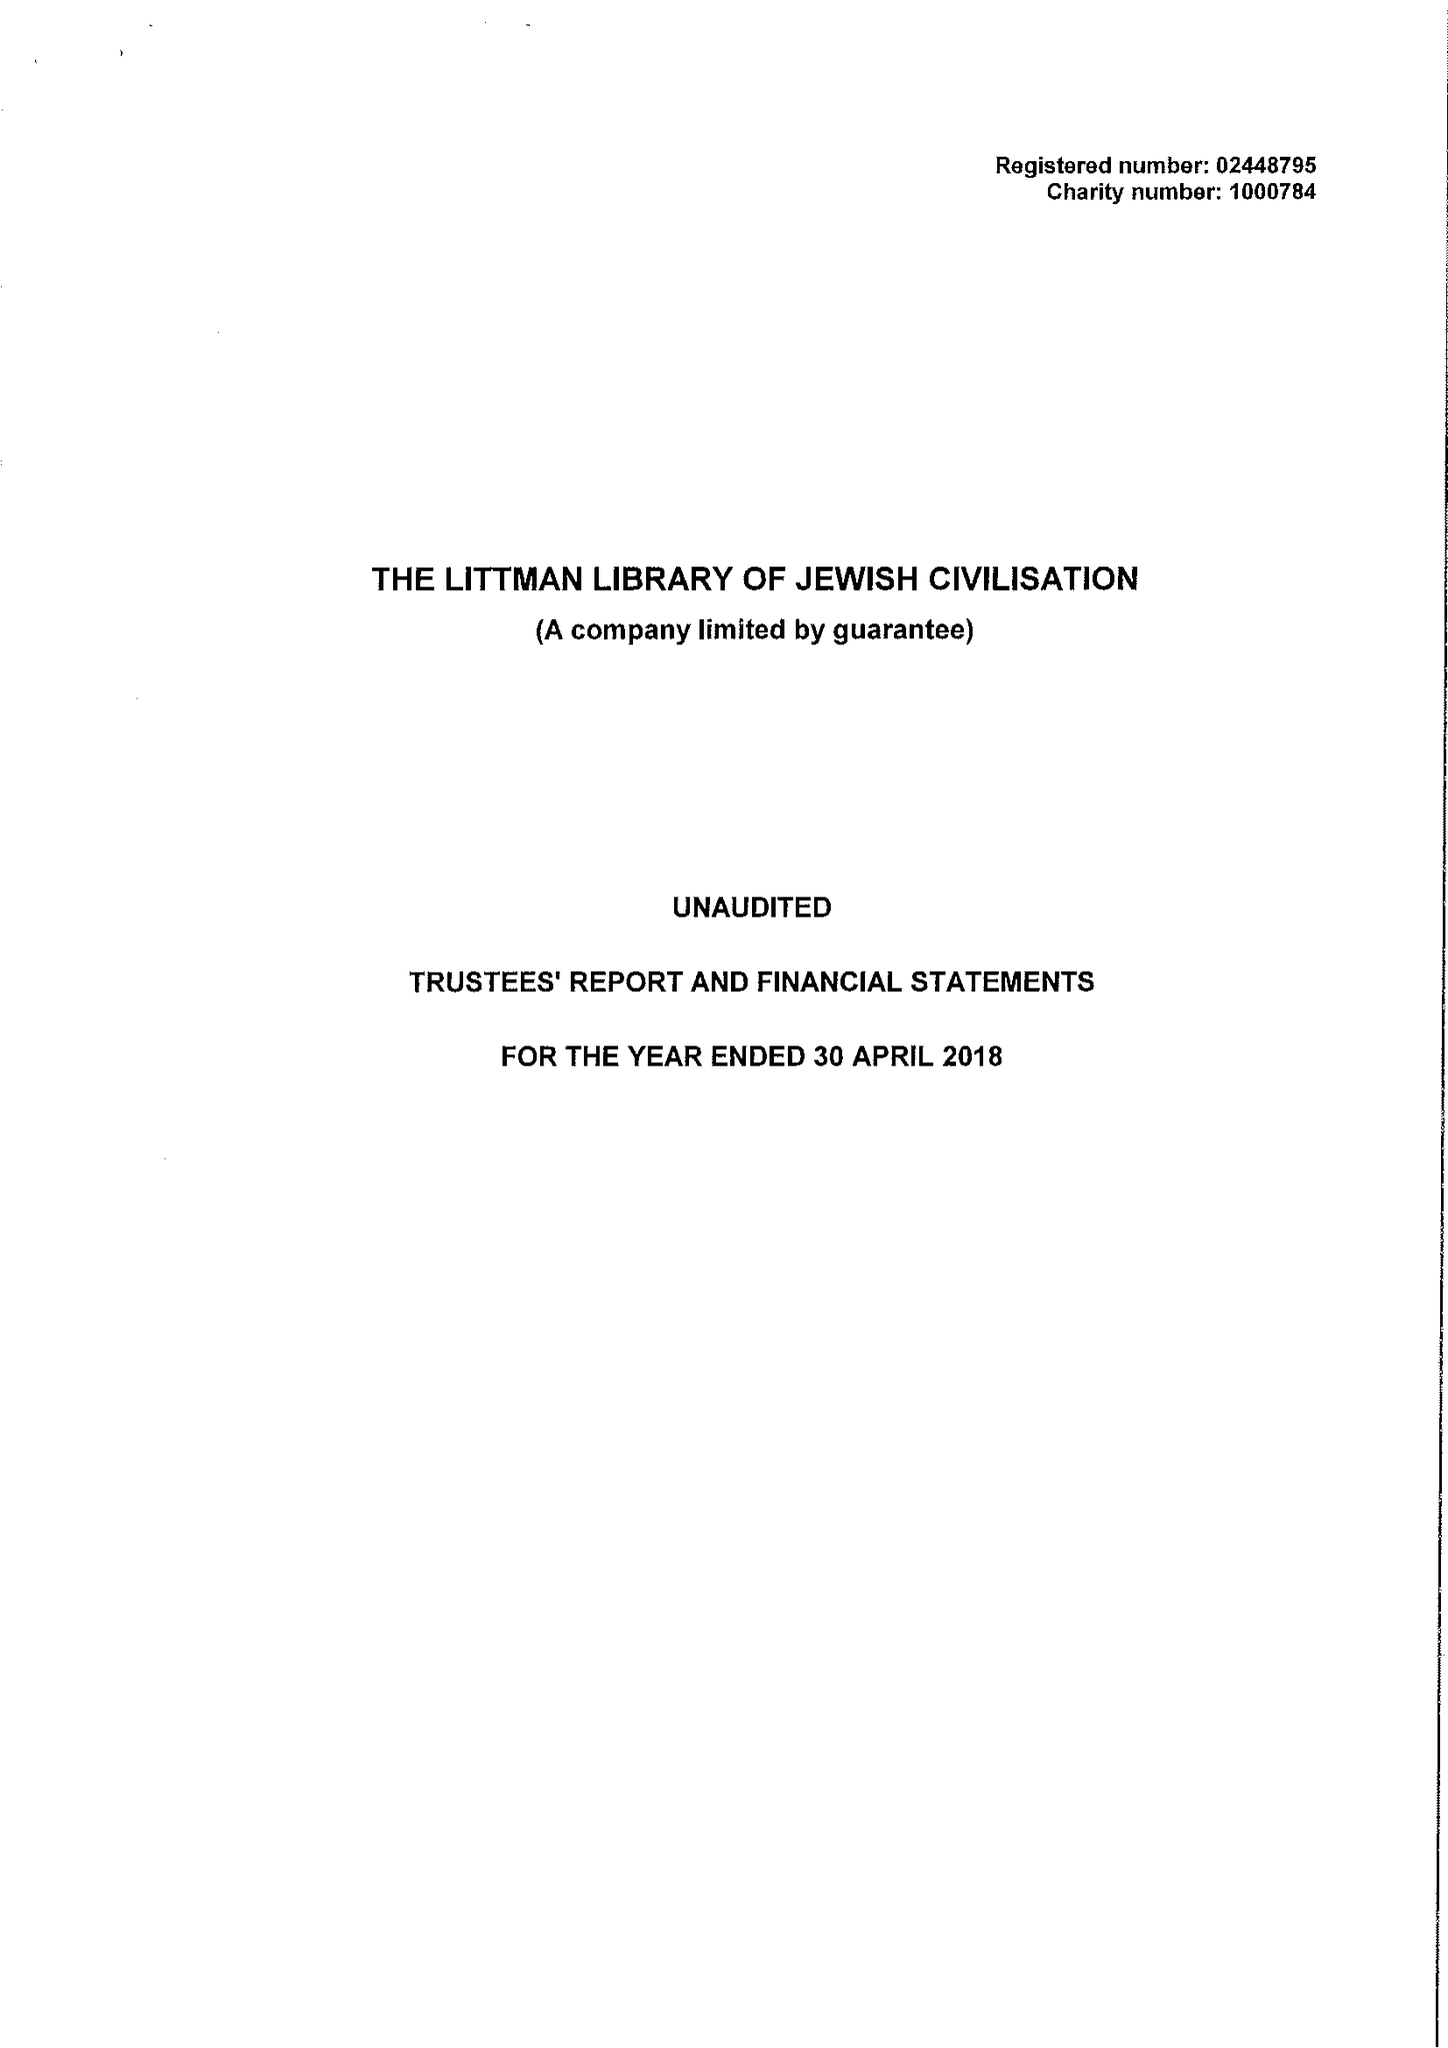What is the value for the charity_name?
Answer the question using a single word or phrase. The Littman Library Of Jewish Civilisation 